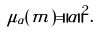Convert formula to latex. <formula><loc_0><loc_0><loc_500><loc_500>\mu _ { \alpha } ( m ) = \| \alpha \| ^ { 2 } .</formula> 